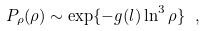Convert formula to latex. <formula><loc_0><loc_0><loc_500><loc_500>P _ { \rho } ( \rho ) \sim \exp \{ - g ( l ) \ln ^ { 3 } \rho \} \ ,</formula> 